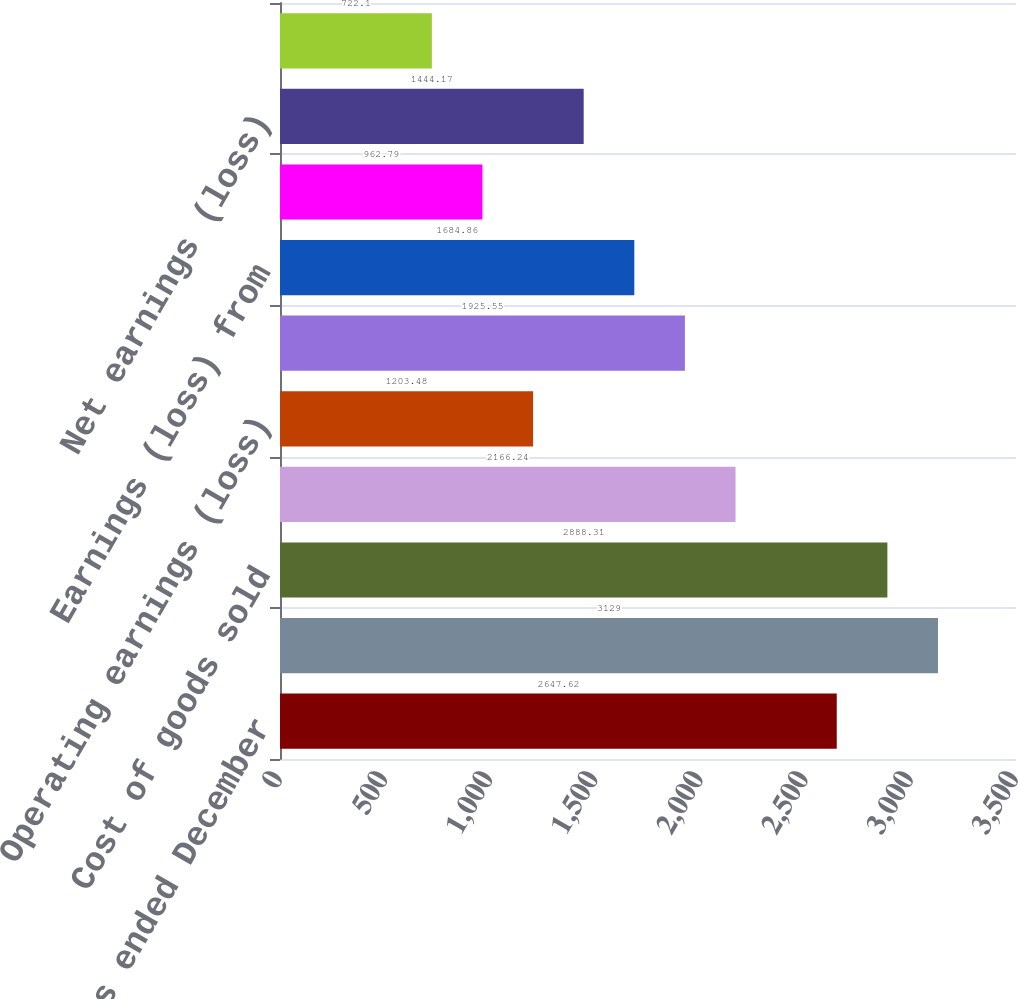Convert chart to OTSL. <chart><loc_0><loc_0><loc_500><loc_500><bar_chart><fcel>For the years ended December<fcel>Net sales<fcel>Cost of goods sold<fcel>Gross profit<fcel>Operating earnings (loss)<fcel>before income taxes<fcel>Earnings (loss) from<fcel>net of income taxes<fcel>Net earnings (loss)<fcel>Continuing operations<nl><fcel>2647.62<fcel>3129<fcel>2888.31<fcel>2166.24<fcel>1203.48<fcel>1925.55<fcel>1684.86<fcel>962.79<fcel>1444.17<fcel>722.1<nl></chart> 